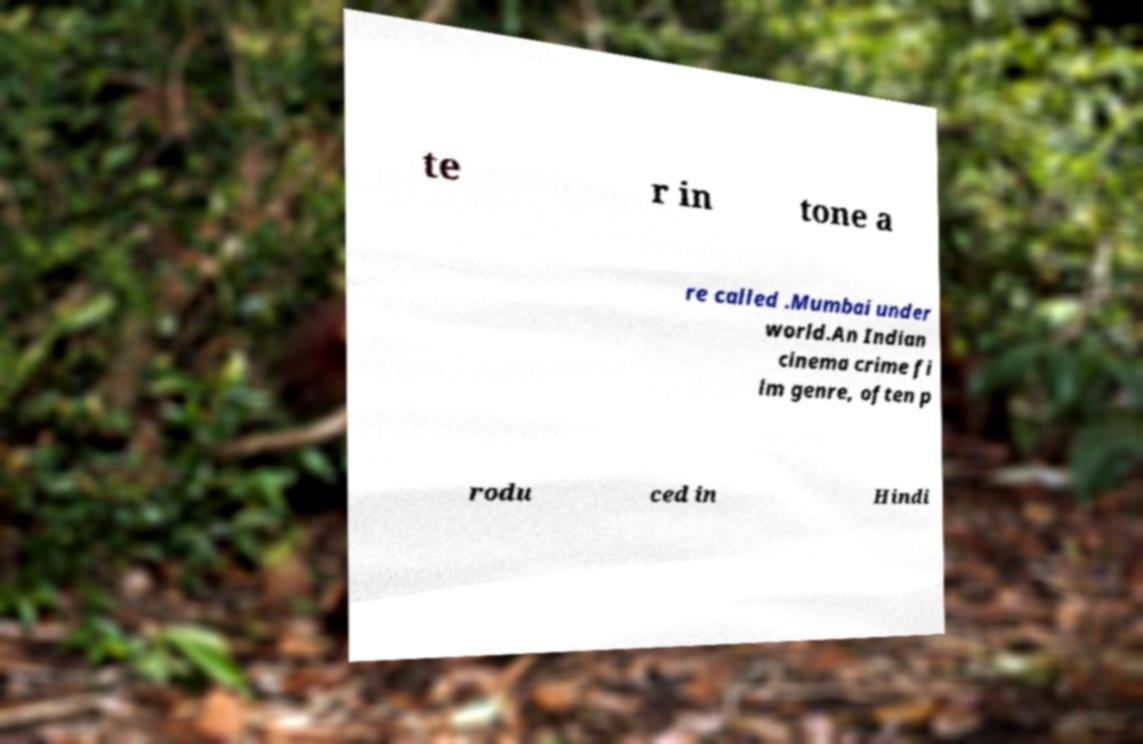I need the written content from this picture converted into text. Can you do that? te r in tone a re called .Mumbai under world.An Indian cinema crime fi lm genre, often p rodu ced in Hindi 